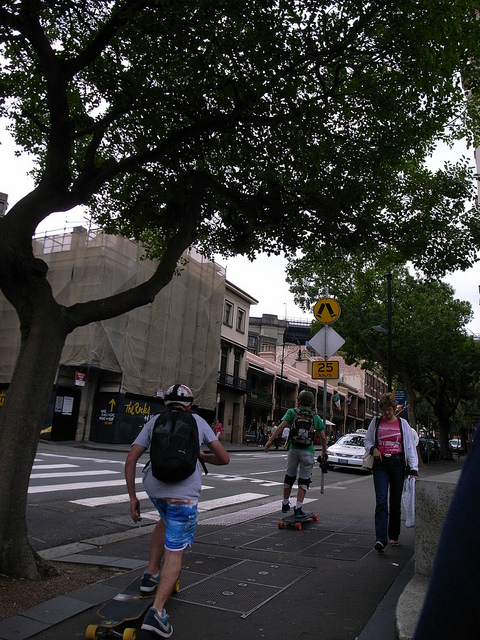Identify the text displayed in this image. 25 